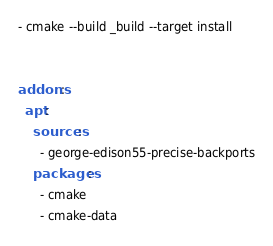Convert code to text. <code><loc_0><loc_0><loc_500><loc_500><_YAML_>- cmake --build _build --target install


addons:
  apt:
    sources:
      - george-edison55-precise-backports
    packages:
      - cmake
      - cmake-data
</code> 